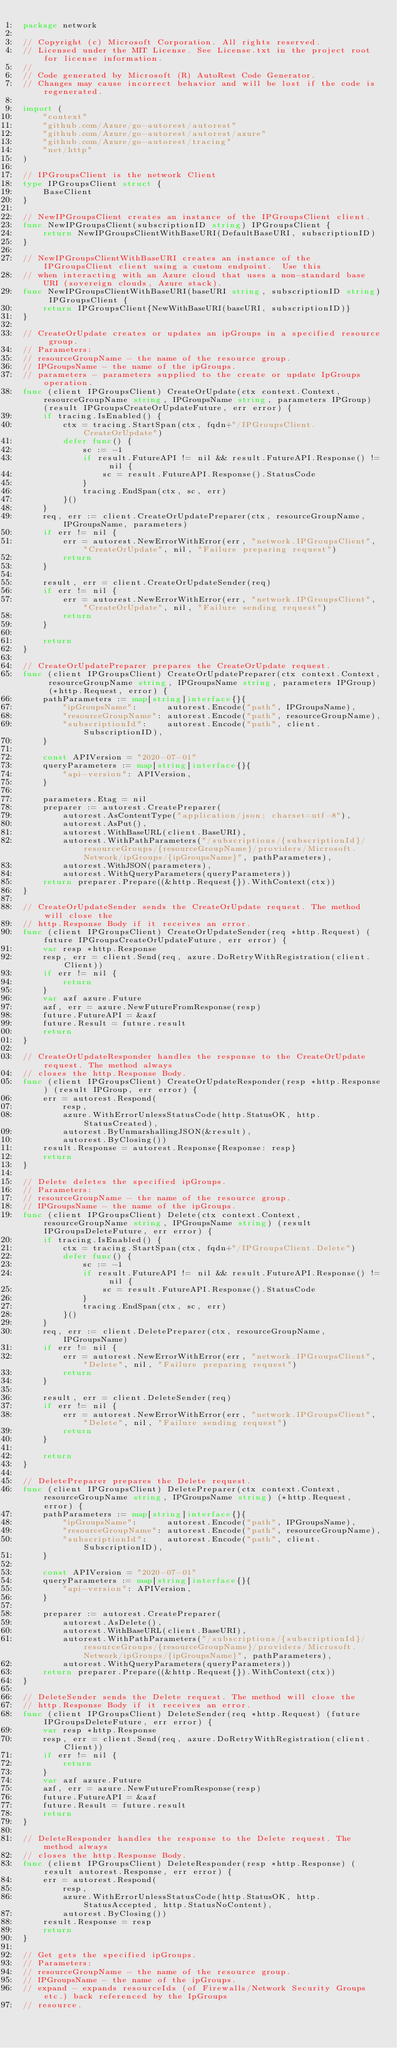<code> <loc_0><loc_0><loc_500><loc_500><_Go_>package network

// Copyright (c) Microsoft Corporation. All rights reserved.
// Licensed under the MIT License. See License.txt in the project root for license information.
//
// Code generated by Microsoft (R) AutoRest Code Generator.
// Changes may cause incorrect behavior and will be lost if the code is regenerated.

import (
	"context"
	"github.com/Azure/go-autorest/autorest"
	"github.com/Azure/go-autorest/autorest/azure"
	"github.com/Azure/go-autorest/tracing"
	"net/http"
)

// IPGroupsClient is the network Client
type IPGroupsClient struct {
	BaseClient
}

// NewIPGroupsClient creates an instance of the IPGroupsClient client.
func NewIPGroupsClient(subscriptionID string) IPGroupsClient {
	return NewIPGroupsClientWithBaseURI(DefaultBaseURI, subscriptionID)
}

// NewIPGroupsClientWithBaseURI creates an instance of the IPGroupsClient client using a custom endpoint.  Use this
// when interacting with an Azure cloud that uses a non-standard base URI (sovereign clouds, Azure stack).
func NewIPGroupsClientWithBaseURI(baseURI string, subscriptionID string) IPGroupsClient {
	return IPGroupsClient{NewWithBaseURI(baseURI, subscriptionID)}
}

// CreateOrUpdate creates or updates an ipGroups in a specified resource group.
// Parameters:
// resourceGroupName - the name of the resource group.
// IPGroupsName - the name of the ipGroups.
// parameters - parameters supplied to the create or update IpGroups operation.
func (client IPGroupsClient) CreateOrUpdate(ctx context.Context, resourceGroupName string, IPGroupsName string, parameters IPGroup) (result IPGroupsCreateOrUpdateFuture, err error) {
	if tracing.IsEnabled() {
		ctx = tracing.StartSpan(ctx, fqdn+"/IPGroupsClient.CreateOrUpdate")
		defer func() {
			sc := -1
			if result.FutureAPI != nil && result.FutureAPI.Response() != nil {
				sc = result.FutureAPI.Response().StatusCode
			}
			tracing.EndSpan(ctx, sc, err)
		}()
	}
	req, err := client.CreateOrUpdatePreparer(ctx, resourceGroupName, IPGroupsName, parameters)
	if err != nil {
		err = autorest.NewErrorWithError(err, "network.IPGroupsClient", "CreateOrUpdate", nil, "Failure preparing request")
		return
	}

	result, err = client.CreateOrUpdateSender(req)
	if err != nil {
		err = autorest.NewErrorWithError(err, "network.IPGroupsClient", "CreateOrUpdate", nil, "Failure sending request")
		return
	}

	return
}

// CreateOrUpdatePreparer prepares the CreateOrUpdate request.
func (client IPGroupsClient) CreateOrUpdatePreparer(ctx context.Context, resourceGroupName string, IPGroupsName string, parameters IPGroup) (*http.Request, error) {
	pathParameters := map[string]interface{}{
		"ipGroupsName":      autorest.Encode("path", IPGroupsName),
		"resourceGroupName": autorest.Encode("path", resourceGroupName),
		"subscriptionId":    autorest.Encode("path", client.SubscriptionID),
	}

	const APIVersion = "2020-07-01"
	queryParameters := map[string]interface{}{
		"api-version": APIVersion,
	}

	parameters.Etag = nil
	preparer := autorest.CreatePreparer(
		autorest.AsContentType("application/json; charset=utf-8"),
		autorest.AsPut(),
		autorest.WithBaseURL(client.BaseURI),
		autorest.WithPathParameters("/subscriptions/{subscriptionId}/resourceGroups/{resourceGroupName}/providers/Microsoft.Network/ipGroups/{ipGroupsName}", pathParameters),
		autorest.WithJSON(parameters),
		autorest.WithQueryParameters(queryParameters))
	return preparer.Prepare((&http.Request{}).WithContext(ctx))
}

// CreateOrUpdateSender sends the CreateOrUpdate request. The method will close the
// http.Response Body if it receives an error.
func (client IPGroupsClient) CreateOrUpdateSender(req *http.Request) (future IPGroupsCreateOrUpdateFuture, err error) {
	var resp *http.Response
	resp, err = client.Send(req, azure.DoRetryWithRegistration(client.Client))
	if err != nil {
		return
	}
	var azf azure.Future
	azf, err = azure.NewFutureFromResponse(resp)
	future.FutureAPI = &azf
	future.Result = future.result
	return
}

// CreateOrUpdateResponder handles the response to the CreateOrUpdate request. The method always
// closes the http.Response Body.
func (client IPGroupsClient) CreateOrUpdateResponder(resp *http.Response) (result IPGroup, err error) {
	err = autorest.Respond(
		resp,
		azure.WithErrorUnlessStatusCode(http.StatusOK, http.StatusCreated),
		autorest.ByUnmarshallingJSON(&result),
		autorest.ByClosing())
	result.Response = autorest.Response{Response: resp}
	return
}

// Delete deletes the specified ipGroups.
// Parameters:
// resourceGroupName - the name of the resource group.
// IPGroupsName - the name of the ipGroups.
func (client IPGroupsClient) Delete(ctx context.Context, resourceGroupName string, IPGroupsName string) (result IPGroupsDeleteFuture, err error) {
	if tracing.IsEnabled() {
		ctx = tracing.StartSpan(ctx, fqdn+"/IPGroupsClient.Delete")
		defer func() {
			sc := -1
			if result.FutureAPI != nil && result.FutureAPI.Response() != nil {
				sc = result.FutureAPI.Response().StatusCode
			}
			tracing.EndSpan(ctx, sc, err)
		}()
	}
	req, err := client.DeletePreparer(ctx, resourceGroupName, IPGroupsName)
	if err != nil {
		err = autorest.NewErrorWithError(err, "network.IPGroupsClient", "Delete", nil, "Failure preparing request")
		return
	}

	result, err = client.DeleteSender(req)
	if err != nil {
		err = autorest.NewErrorWithError(err, "network.IPGroupsClient", "Delete", nil, "Failure sending request")
		return
	}

	return
}

// DeletePreparer prepares the Delete request.
func (client IPGroupsClient) DeletePreparer(ctx context.Context, resourceGroupName string, IPGroupsName string) (*http.Request, error) {
	pathParameters := map[string]interface{}{
		"ipGroupsName":      autorest.Encode("path", IPGroupsName),
		"resourceGroupName": autorest.Encode("path", resourceGroupName),
		"subscriptionId":    autorest.Encode("path", client.SubscriptionID),
	}

	const APIVersion = "2020-07-01"
	queryParameters := map[string]interface{}{
		"api-version": APIVersion,
	}

	preparer := autorest.CreatePreparer(
		autorest.AsDelete(),
		autorest.WithBaseURL(client.BaseURI),
		autorest.WithPathParameters("/subscriptions/{subscriptionId}/resourceGroups/{resourceGroupName}/providers/Microsoft.Network/ipGroups/{ipGroupsName}", pathParameters),
		autorest.WithQueryParameters(queryParameters))
	return preparer.Prepare((&http.Request{}).WithContext(ctx))
}

// DeleteSender sends the Delete request. The method will close the
// http.Response Body if it receives an error.
func (client IPGroupsClient) DeleteSender(req *http.Request) (future IPGroupsDeleteFuture, err error) {
	var resp *http.Response
	resp, err = client.Send(req, azure.DoRetryWithRegistration(client.Client))
	if err != nil {
		return
	}
	var azf azure.Future
	azf, err = azure.NewFutureFromResponse(resp)
	future.FutureAPI = &azf
	future.Result = future.result
	return
}

// DeleteResponder handles the response to the Delete request. The method always
// closes the http.Response Body.
func (client IPGroupsClient) DeleteResponder(resp *http.Response) (result autorest.Response, err error) {
	err = autorest.Respond(
		resp,
		azure.WithErrorUnlessStatusCode(http.StatusOK, http.StatusAccepted, http.StatusNoContent),
		autorest.ByClosing())
	result.Response = resp
	return
}

// Get gets the specified ipGroups.
// Parameters:
// resourceGroupName - the name of the resource group.
// IPGroupsName - the name of the ipGroups.
// expand - expands resourceIds (of Firewalls/Network Security Groups etc.) back referenced by the IpGroups
// resource.</code> 